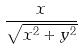Convert formula to latex. <formula><loc_0><loc_0><loc_500><loc_500>\frac { x } { \sqrt { x ^ { 2 } + y ^ { 2 } } }</formula> 